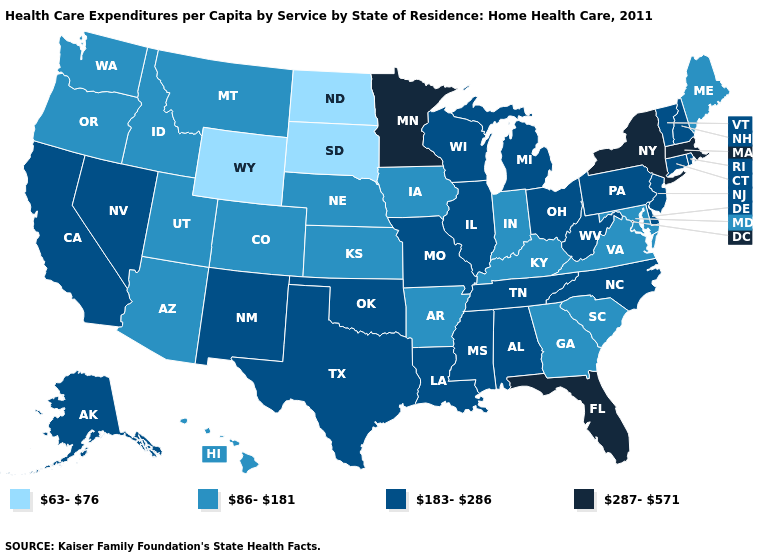What is the value of West Virginia?
Short answer required. 183-286. Among the states that border Illinois , which have the highest value?
Give a very brief answer. Missouri, Wisconsin. Is the legend a continuous bar?
Give a very brief answer. No. What is the value of Nebraska?
Concise answer only. 86-181. What is the value of Colorado?
Keep it brief. 86-181. What is the value of Georgia?
Give a very brief answer. 86-181. Name the states that have a value in the range 63-76?
Answer briefly. North Dakota, South Dakota, Wyoming. Name the states that have a value in the range 86-181?
Write a very short answer. Arizona, Arkansas, Colorado, Georgia, Hawaii, Idaho, Indiana, Iowa, Kansas, Kentucky, Maine, Maryland, Montana, Nebraska, Oregon, South Carolina, Utah, Virginia, Washington. What is the value of Mississippi?
Be succinct. 183-286. Does Maine have the lowest value in the Northeast?
Be succinct. Yes. What is the value of Montana?
Give a very brief answer. 86-181. Name the states that have a value in the range 183-286?
Concise answer only. Alabama, Alaska, California, Connecticut, Delaware, Illinois, Louisiana, Michigan, Mississippi, Missouri, Nevada, New Hampshire, New Jersey, New Mexico, North Carolina, Ohio, Oklahoma, Pennsylvania, Rhode Island, Tennessee, Texas, Vermont, West Virginia, Wisconsin. What is the highest value in states that border Indiana?
Give a very brief answer. 183-286. What is the value of North Carolina?
Be succinct. 183-286. Name the states that have a value in the range 183-286?
Give a very brief answer. Alabama, Alaska, California, Connecticut, Delaware, Illinois, Louisiana, Michigan, Mississippi, Missouri, Nevada, New Hampshire, New Jersey, New Mexico, North Carolina, Ohio, Oklahoma, Pennsylvania, Rhode Island, Tennessee, Texas, Vermont, West Virginia, Wisconsin. 